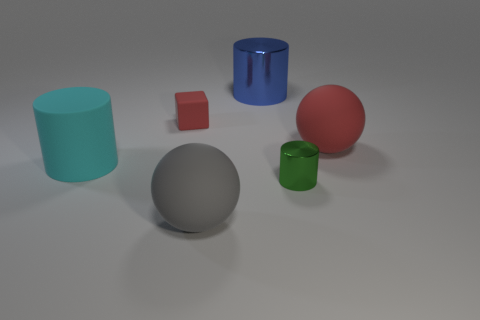Are the ball that is right of the gray matte sphere and the green object made of the same material?
Offer a terse response. No. The large cyan thing is what shape?
Your answer should be very brief. Cylinder. What number of large things are behind the large rubber sphere that is to the right of the large matte ball that is in front of the tiny green object?
Ensure brevity in your answer.  1. What number of other things are the same material as the red block?
Provide a succinct answer. 3. What material is the gray thing that is the same size as the blue cylinder?
Your response must be concise. Rubber. Is the color of the big rubber thing that is in front of the small green metallic cylinder the same as the matte object on the right side of the green cylinder?
Make the answer very short. No. Is there a blue thing that has the same shape as the large cyan object?
Give a very brief answer. Yes. There is a gray object that is the same size as the cyan matte cylinder; what shape is it?
Provide a short and direct response. Sphere. What number of other blocks have the same color as the small matte block?
Ensure brevity in your answer.  0. There is a cylinder that is to the right of the large blue object; what size is it?
Your response must be concise. Small. 